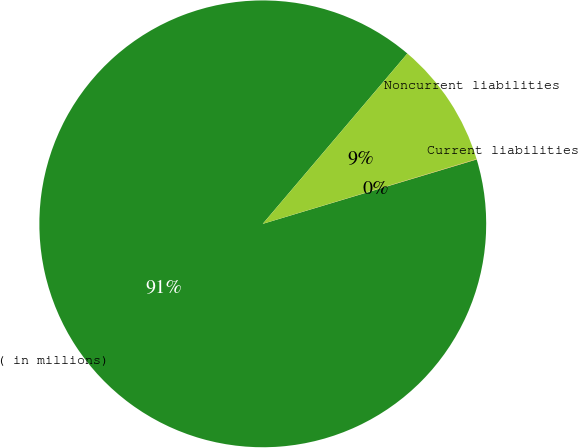Convert chart. <chart><loc_0><loc_0><loc_500><loc_500><pie_chart><fcel>( in millions)<fcel>Current liabilities<fcel>Noncurrent liabilities<nl><fcel>90.85%<fcel>0.03%<fcel>9.11%<nl></chart> 